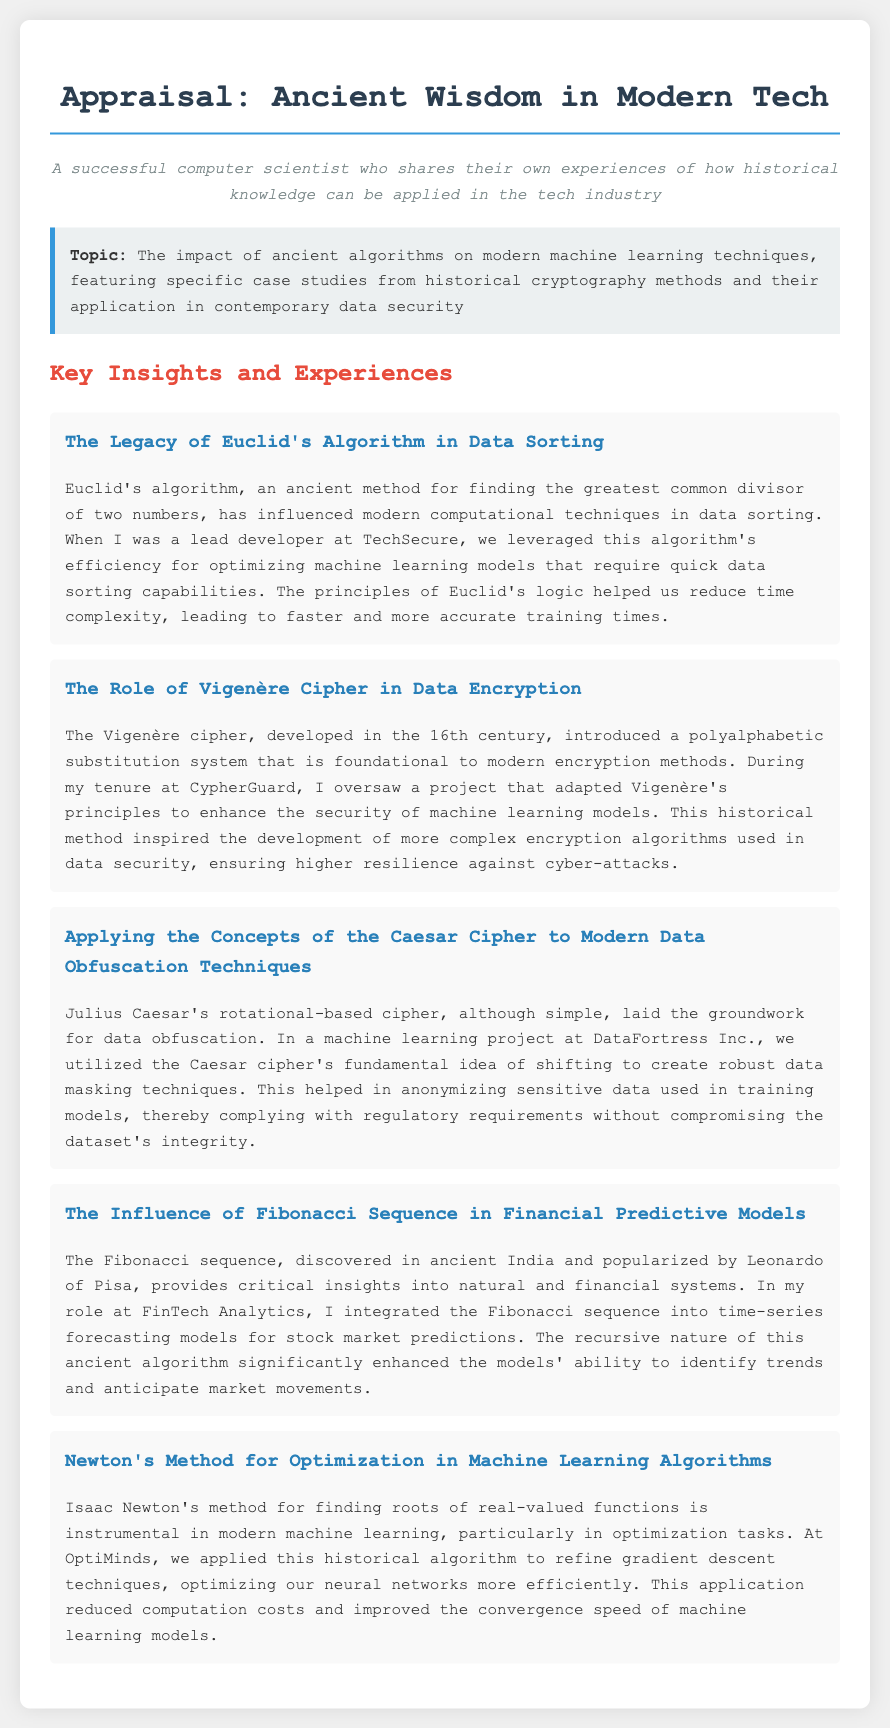What is the title of the document? The title is presented in the main heading at the top of the document.
Answer: Appraisal: Ancient Wisdom in Modern Tech What algorithm influenced modern computational techniques in data sorting? The specific algorithm is mentioned within the context of the document under its legacy.
Answer: Euclid's Algorithm Which cipher's principles were adapted to enhance data security at CypherGuard? This cipher is noted in the section discussing historical cryptography methods.
Answer: Vigenère Cipher What ancient sequence was integrated into time-series forecasting models? The sequence is highlighted in the context of financial predictive models in the document.
Answer: Fibonacci Sequence At which company was Newton's method applied to optimize machine learning algorithms? The company name is mentioned in the relevant section discussing optimization.
Answer: OptiMinds Which historical figure is associated with a rotational-based cipher? The figure is critically discussed in relation to data obfuscation techniques.
Answer: Julius Caesar What was the main benefit of applying Newton's method as mentioned? The benefit is emphasized in the discussion regarding machine learning tasks and performance.
Answer: Improved convergence speed Which historical method inspired the development of more complex encryption algorithms? This method is linked to modern encryption in the project overseen at CypherGuard.
Answer: Vigenère Cipher In which project was the Caesar cipher's fundamental idea utilized? The project is cited within the context of data masking techniques in the document.
Answer: DataFortress Inc What type of techniques were enhanced by the Vigenère cipher? The type mentioned relates directly to modern implementations in security.
Answer: Encryption techniques 